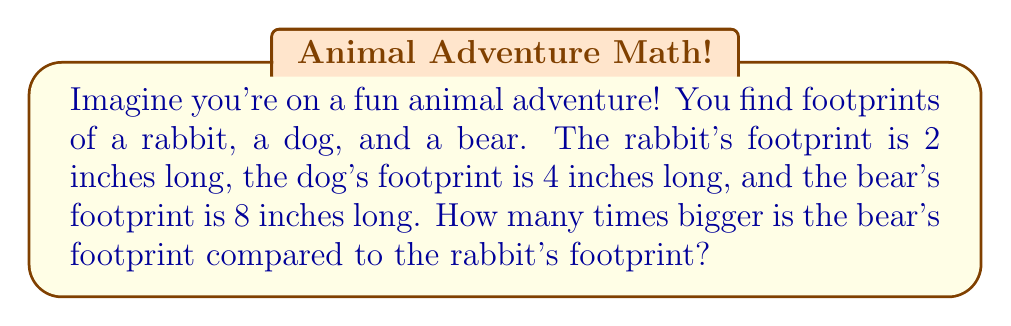Can you solve this math problem? Let's solve this step by step:

1. First, we need to understand what the question is asking. We want to know how many times bigger the bear's footprint is compared to the rabbit's footprint.

2. We can do this by dividing the length of the bear's footprint by the length of the rabbit's footprint:

   $$\frac{\text{Bear's footprint length}}{\text{Rabbit's footprint length}} = \frac{8 \text{ inches}}{2 \text{ inches}}$$

3. Now, let's do the division:
   
   $$\frac{8}{2} = 4$$

4. This means the bear's footprint is 4 times bigger than the rabbit's footprint.

5. We can check this by seeing that:
   - 2 inches × 4 = 8 inches
   
   Which confirms that if we multiply the rabbit's footprint length by 4, we get the bear's footprint length.

[asy]
unitsize(1cm);
draw((0,0)--(2,0), linewidth(2));
label("Rabbit (2 inches)", (1,-0.5));
draw((0,-2)--(4,-2), linewidth(2));
label("Dog (4 inches)", (2,-2.5));
draw((0,-4)--(8,-4), linewidth(2));
label("Bear (8 inches)", (4,-4.5));
[/asy]

This picture shows the relative sizes of the footprints to help visualize the difference.
Answer: The bear's footprint is 4 times bigger than the rabbit's footprint. 